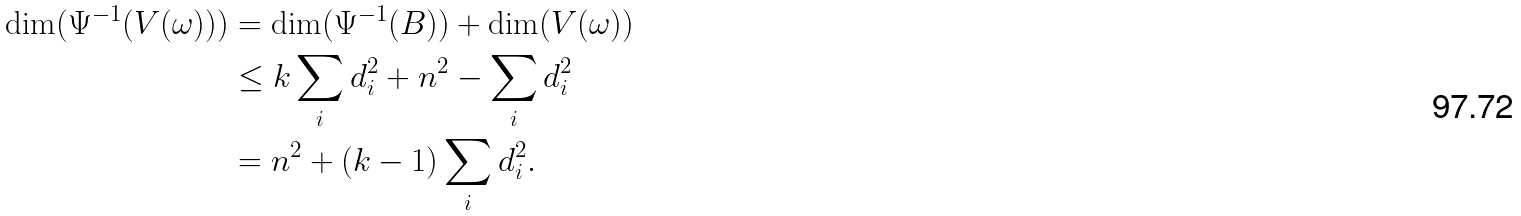Convert formula to latex. <formula><loc_0><loc_0><loc_500><loc_500>\dim ( \Psi ^ { - 1 } ( V ( \omega ) ) ) & = \dim ( \Psi ^ { - 1 } ( B ) ) + \dim ( V ( \omega ) ) \\ & \leq k \sum _ { i } d _ { i } ^ { 2 } + n ^ { 2 } - \sum _ { i } d _ { i } ^ { 2 } \\ & = n ^ { 2 } + ( k - 1 ) \sum _ { i } d _ { i } ^ { 2 } .</formula> 